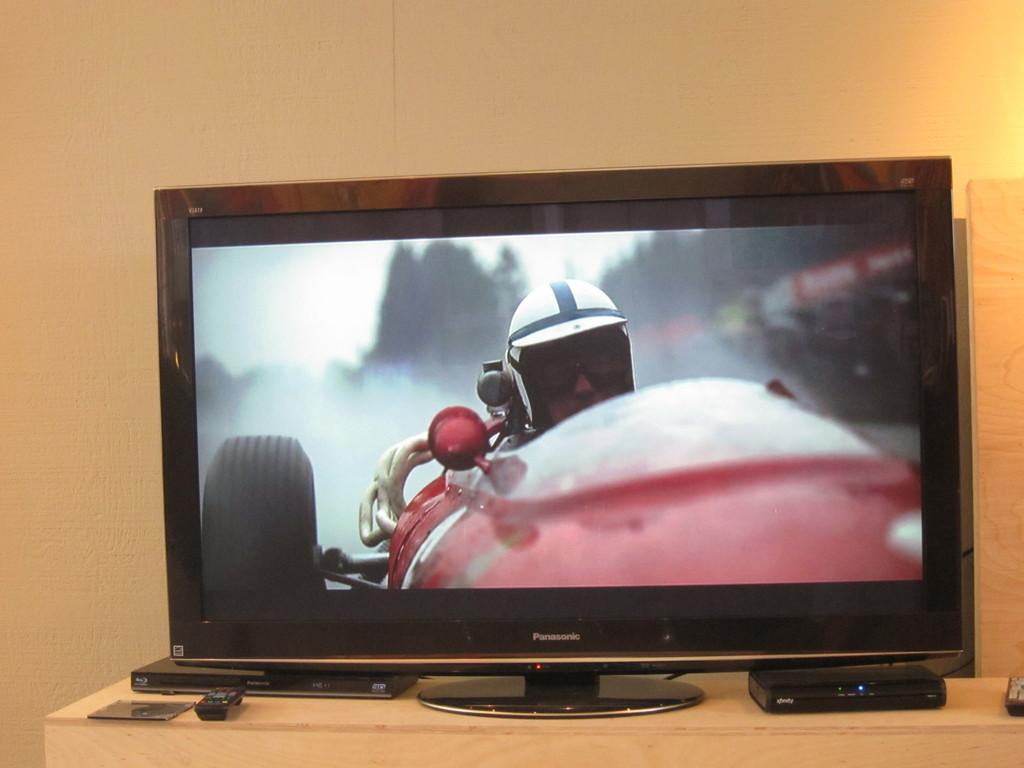<image>
Describe the image concisely. a tv that has the word Panasonic on it 